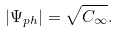<formula> <loc_0><loc_0><loc_500><loc_500>| \Psi _ { p h } | = \sqrt { C _ { \infty } } .</formula> 